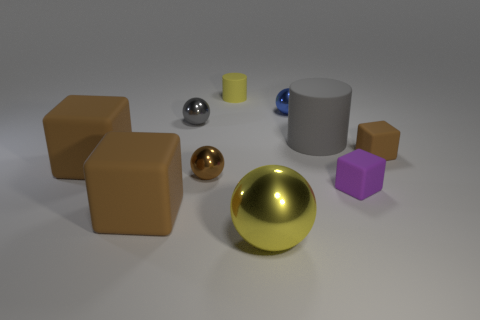There is a object that is the same color as the tiny cylinder; what size is it?
Give a very brief answer. Large. What is the color of the matte cylinder on the right side of the tiny yellow rubber object?
Your response must be concise. Gray. Does the small purple matte thing have the same shape as the tiny brown matte object?
Offer a terse response. Yes. There is a rubber cube that is both in front of the tiny brown sphere and right of the big yellow ball; what is its color?
Keep it short and to the point. Purple. There is a gray thing behind the big gray cylinder; is its size the same as the gray matte cylinder that is to the right of the gray shiny ball?
Ensure brevity in your answer.  No. What number of things are cylinders that are behind the gray rubber cylinder or small gray shiny things?
Offer a very short reply. 2. What is the gray cylinder made of?
Your answer should be compact. Rubber. Do the purple cube and the yellow shiny thing have the same size?
Provide a short and direct response. No. How many cubes are big things or large gray things?
Your response must be concise. 2. The cylinder that is left of the yellow thing that is in front of the yellow cylinder is what color?
Your response must be concise. Yellow. 